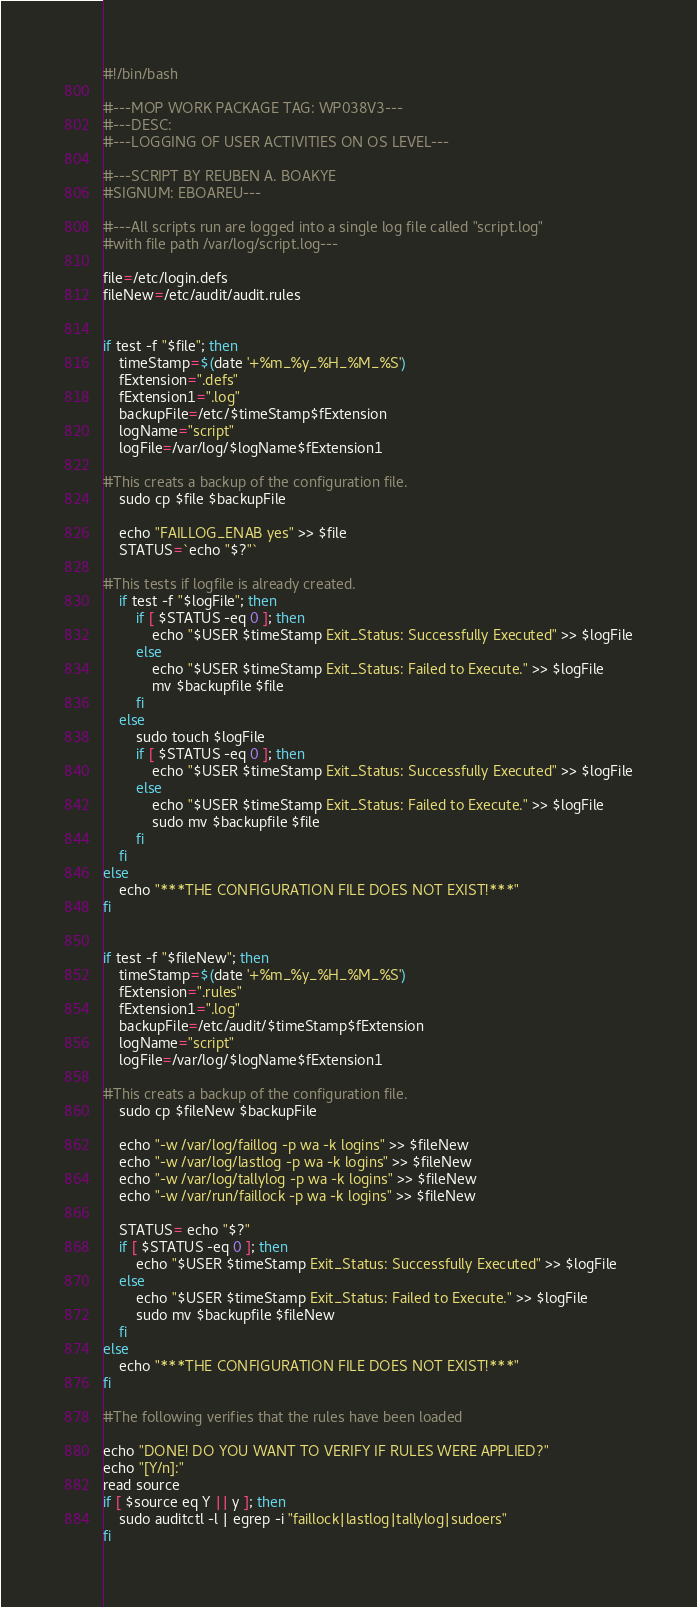Convert code to text. <code><loc_0><loc_0><loc_500><loc_500><_Bash_>#!/bin/bash

#---MOP WORK PACKAGE TAG: WP038V3---
#---DESC:
#---LOGGING OF USER ACTIVITIES ON OS LEVEL---

#---SCRIPT BY REUBEN A. BOAKYE
#SIGNUM: EBOAREU---

#---All scripts run are logged into a single log file called "script.log"
#with file path /var/log/script.log---

file=/etc/login.defs
fileNew=/etc/audit/audit.rules


if test -f "$file"; then
	timeStamp=$(date '+%m_%y_%H_%M_%S')
	fExtension=".defs"
	fExtension1=".log"
	backupFile=/etc/$timeStamp$fExtension
	logName="script"
	logFile=/var/log/$logName$fExtension1

#This creats a backup of the configuration file.
	sudo cp $file $backupFile

	echo "FAILLOG_ENAB yes" >> $file
	STATUS=`echo "$?"`

#This tests if logfile is already created.
	if test -f "$logFile"; then 
		if [ $STATUS -eq 0 ]; then
			echo "$USER $timeStamp Exit_Status: Successfully Executed" >> $logFile
		else
			echo "$USER $timeStamp Exit_Status: Failed to Execute." >> $logFile
			mv $backupfile $file
		fi
	else
		sudo touch $logFile
		if [ $STATUS -eq 0 ]; then
			echo "$USER $timeStamp Exit_Status: Successfully Executed" >> $logFile
		else
			echo "$USER $timeStamp Exit_Status: Failed to Execute." >> $logFile
			sudo mv $backupfile $file
		fi
	fi
else 
	echo "***THE CONFIGURATION FILE DOES NOT EXIST!***"
fi


if test -f "$fileNew"; then
	timeStamp=$(date '+%m_%y_%H_%M_%S')
	fExtension=".rules"
	fExtension1=".log"
	backupFile=/etc/audit/$timeStamp$fExtension
	logName="script"
	logFile=/var/log/$logName$fExtension1

#This creats a backup of the configuration file.
	sudo cp $fileNew $backupFile

	echo "-w /var/log/faillog -p wa -k logins" >> $fileNew
	echo "-w /var/log/lastlog -p wa -k logins" >> $fileNew
	echo "-w /var/log/tallylog -p wa -k logins" >> $fileNew
	echo "-w /var/run/faillock -p wa -k logins" >> $fileNew

	STATUS= echo "$?"
	if [ $STATUS -eq 0 ]; then
		echo "$USER $timeStamp Exit_Status: Successfully Executed" >> $logFile
	else 
		echo "$USER $timeStamp Exit_Status: Failed to Execute." >> $logFile
		sudo mv $backupfile $fileNew
	fi
else 
	echo "***THE CONFIGURATION FILE DOES NOT EXIST!***"
fi

#The following verifies that the rules have been loaded

echo "DONE! DO YOU WANT TO VERIFY IF RULES WERE APPLIED?"
echo "[Y/n]:"
read source
if [ $source eq Y || y ]; then
	sudo auditctl -l | egrep -i "faillock|lastlog|tallylog|sudoers"
fi

</code> 